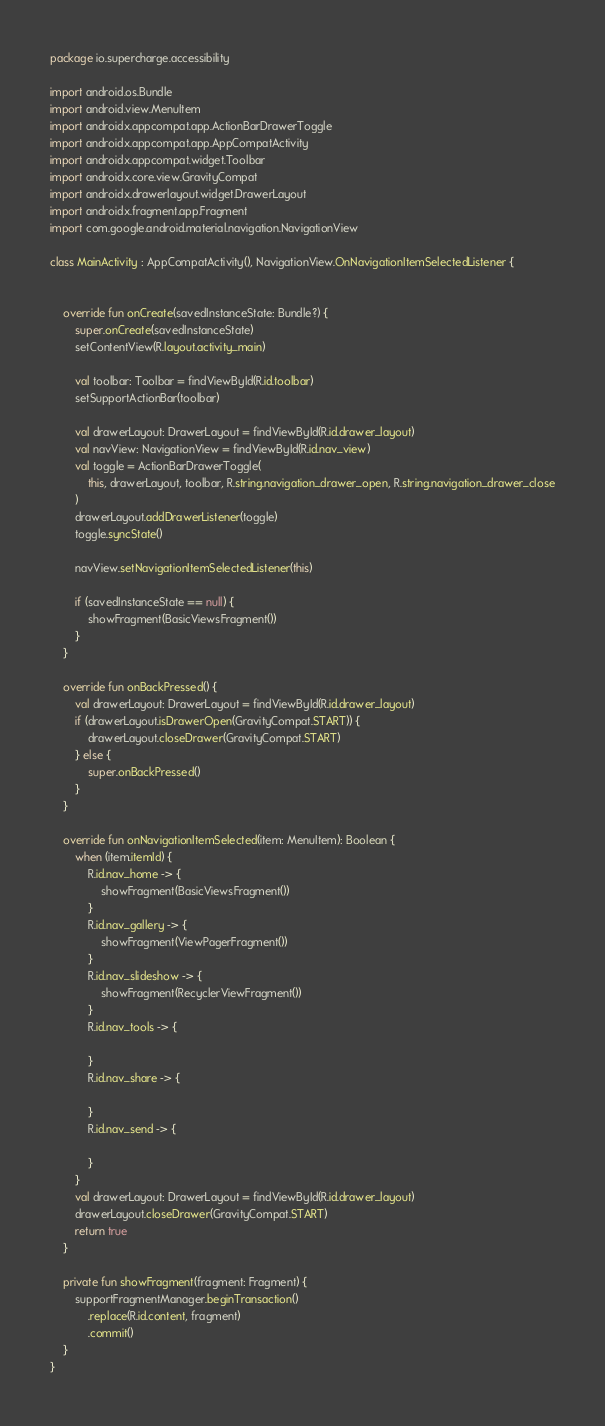Convert code to text. <code><loc_0><loc_0><loc_500><loc_500><_Kotlin_>package io.supercharge.accessibility

import android.os.Bundle
import android.view.MenuItem
import androidx.appcompat.app.ActionBarDrawerToggle
import androidx.appcompat.app.AppCompatActivity
import androidx.appcompat.widget.Toolbar
import androidx.core.view.GravityCompat
import androidx.drawerlayout.widget.DrawerLayout
import androidx.fragment.app.Fragment
import com.google.android.material.navigation.NavigationView

class MainActivity : AppCompatActivity(), NavigationView.OnNavigationItemSelectedListener {


    override fun onCreate(savedInstanceState: Bundle?) {
        super.onCreate(savedInstanceState)
        setContentView(R.layout.activity_main)

        val toolbar: Toolbar = findViewById(R.id.toolbar)
        setSupportActionBar(toolbar)

        val drawerLayout: DrawerLayout = findViewById(R.id.drawer_layout)
        val navView: NavigationView = findViewById(R.id.nav_view)
        val toggle = ActionBarDrawerToggle(
            this, drawerLayout, toolbar, R.string.navigation_drawer_open, R.string.navigation_drawer_close
        )
        drawerLayout.addDrawerListener(toggle)
        toggle.syncState()

        navView.setNavigationItemSelectedListener(this)

        if (savedInstanceState == null) {
            showFragment(BasicViewsFragment())
        }
    }

    override fun onBackPressed() {
        val drawerLayout: DrawerLayout = findViewById(R.id.drawer_layout)
        if (drawerLayout.isDrawerOpen(GravityCompat.START)) {
            drawerLayout.closeDrawer(GravityCompat.START)
        } else {
            super.onBackPressed()
        }
    }

    override fun onNavigationItemSelected(item: MenuItem): Boolean {
        when (item.itemId) {
            R.id.nav_home -> {
                showFragment(BasicViewsFragment())
            }
            R.id.nav_gallery -> {
                showFragment(ViewPagerFragment())
            }
            R.id.nav_slideshow -> {
                showFragment(RecyclerViewFragment())
            }
            R.id.nav_tools -> {

            }
            R.id.nav_share -> {

            }
            R.id.nav_send -> {

            }
        }
        val drawerLayout: DrawerLayout = findViewById(R.id.drawer_layout)
        drawerLayout.closeDrawer(GravityCompat.START)
        return true
    }

    private fun showFragment(fragment: Fragment) {
        supportFragmentManager.beginTransaction()
            .replace(R.id.content, fragment)
            .commit()
    }
}
</code> 